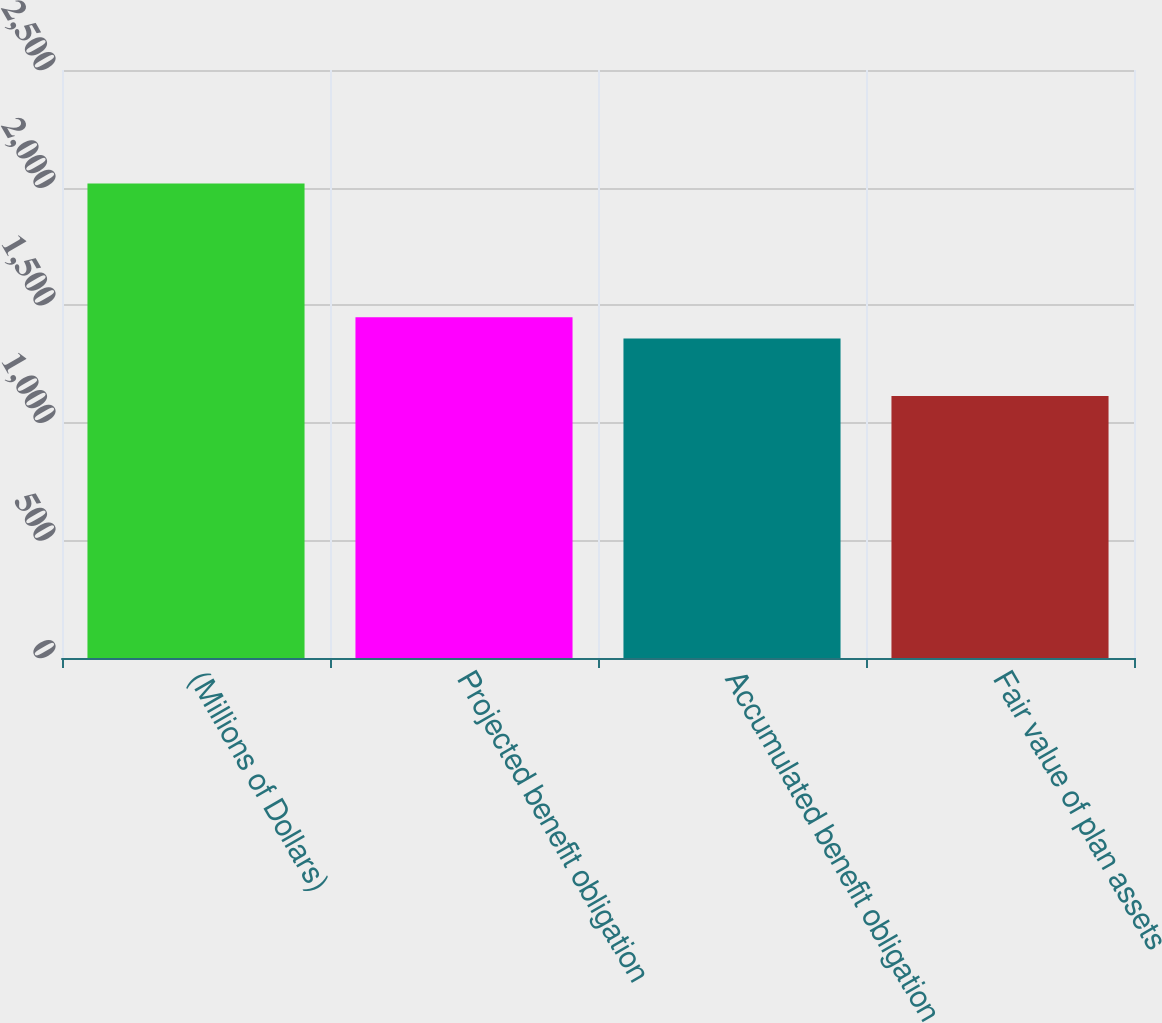Convert chart. <chart><loc_0><loc_0><loc_500><loc_500><bar_chart><fcel>(Millions of Dollars)<fcel>Projected benefit obligation<fcel>Accumulated benefit obligation<fcel>Fair value of plan assets<nl><fcel>2017<fcel>1448.69<fcel>1358.4<fcel>1114.1<nl></chart> 